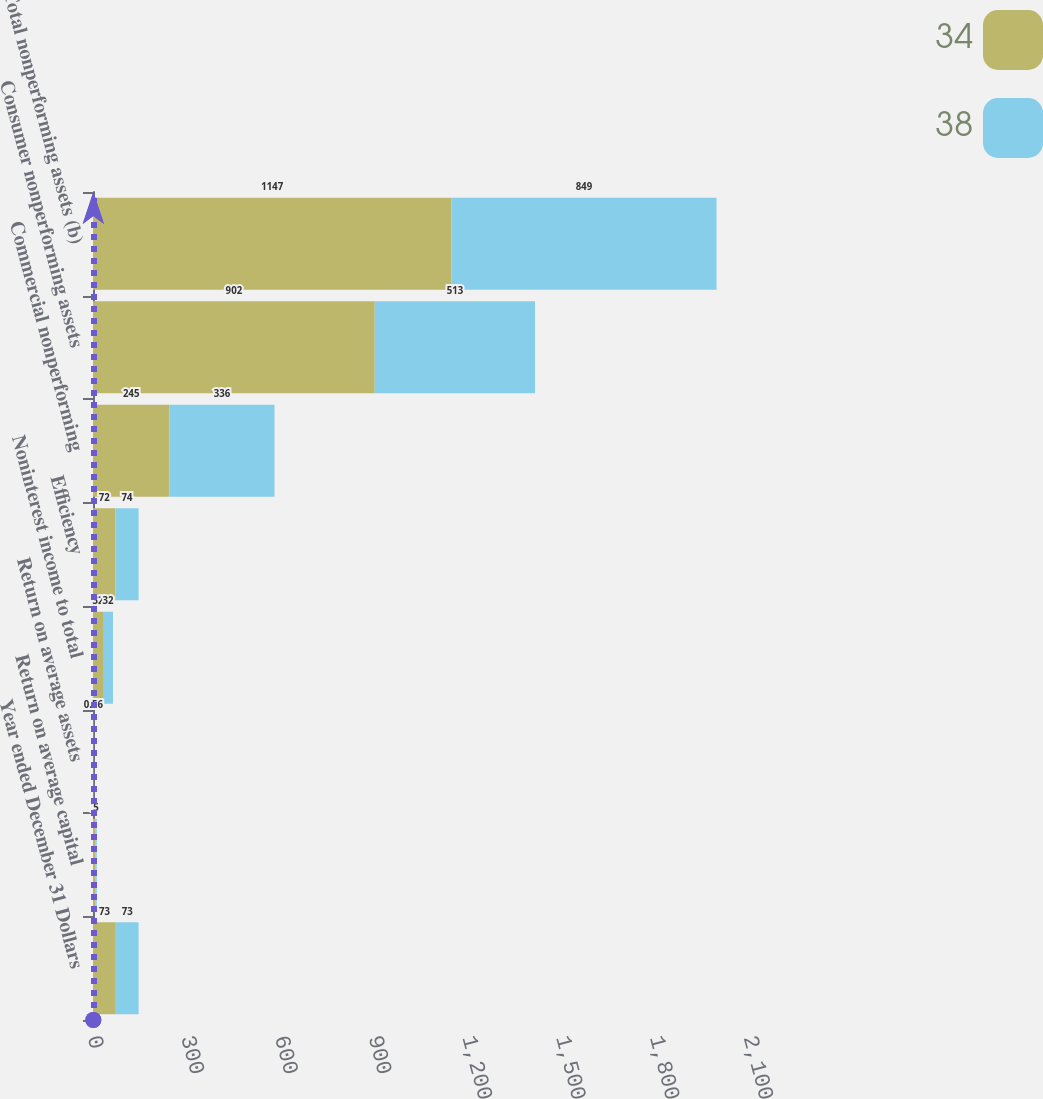<chart> <loc_0><loc_0><loc_500><loc_500><stacked_bar_chart><ecel><fcel>Year ended December 31 Dollars<fcel>Return on average capital<fcel>Return on average assets<fcel>Noninterest income to total<fcel>Efficiency<fcel>Commercial nonperforming<fcel>Consumer nonperforming assets<fcel>Total nonperforming assets (b)<nl><fcel>34<fcel>73<fcel>7<fcel>0.82<fcel>32<fcel>72<fcel>245<fcel>902<fcel>1147<nl><fcel>38<fcel>73<fcel>5<fcel>0.56<fcel>32<fcel>74<fcel>336<fcel>513<fcel>849<nl></chart> 